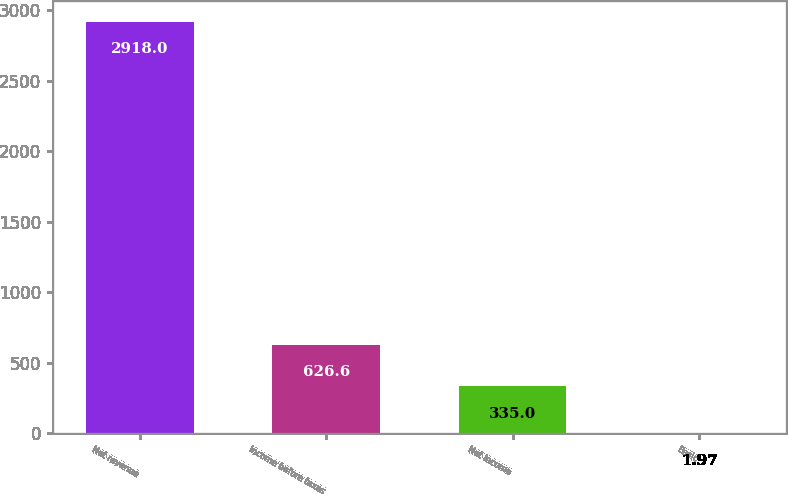<chart> <loc_0><loc_0><loc_500><loc_500><bar_chart><fcel>Net revenue<fcel>Income before taxes<fcel>Net income<fcel>Basic<nl><fcel>2918<fcel>626.6<fcel>335<fcel>1.97<nl></chart> 